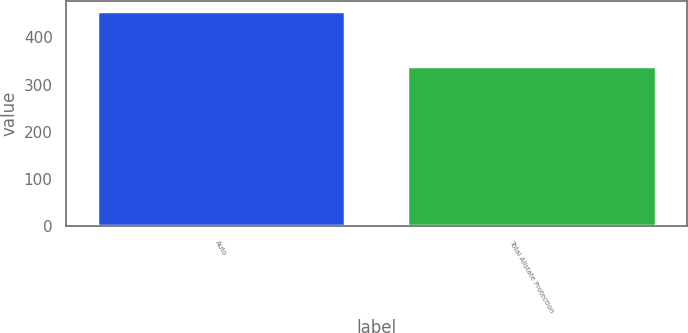Convert chart to OTSL. <chart><loc_0><loc_0><loc_500><loc_500><bar_chart><fcel>Auto<fcel>Total Allstate Protection<nl><fcel>455<fcel>340<nl></chart> 